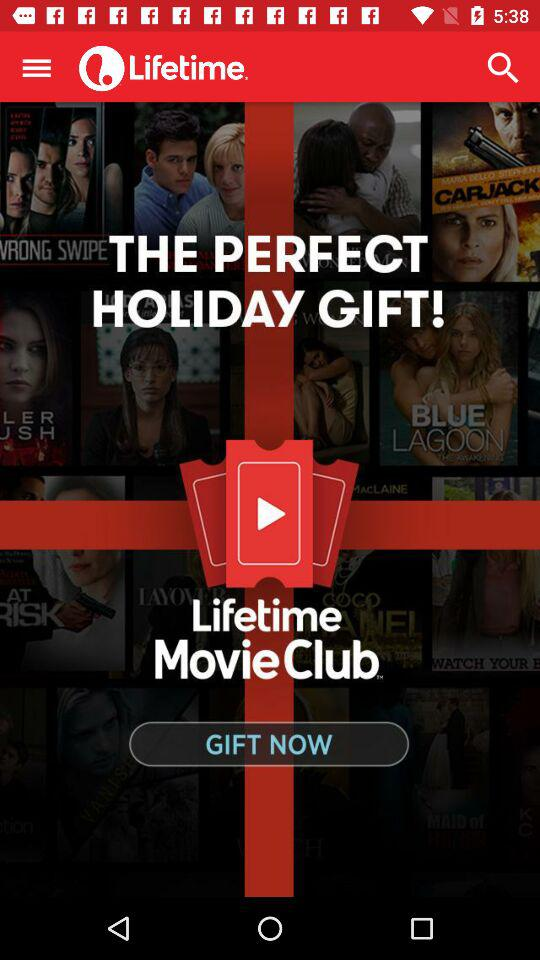What is the application name? The application name is "Lifetime". 